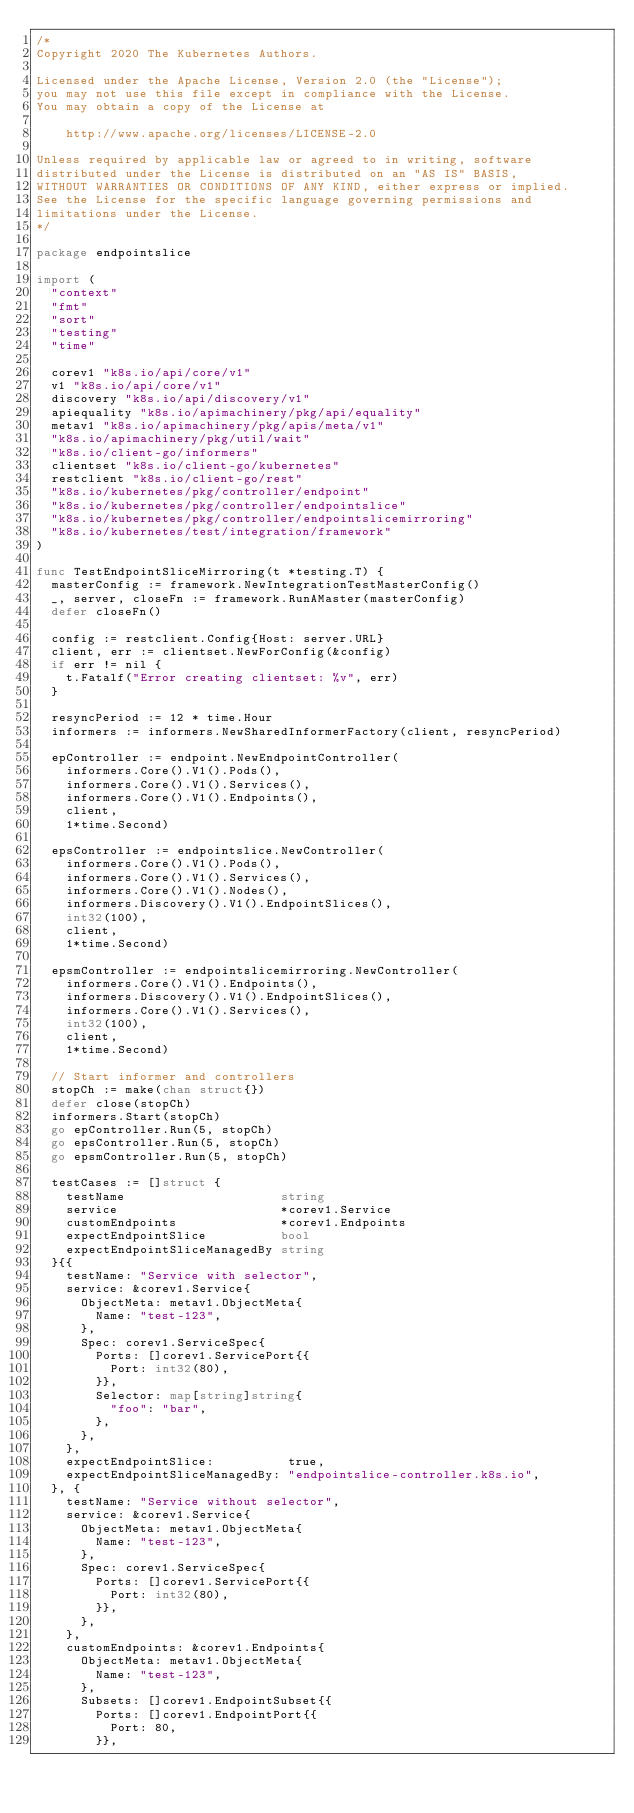Convert code to text. <code><loc_0><loc_0><loc_500><loc_500><_Go_>/*
Copyright 2020 The Kubernetes Authors.

Licensed under the Apache License, Version 2.0 (the "License");
you may not use this file except in compliance with the License.
You may obtain a copy of the License at

    http://www.apache.org/licenses/LICENSE-2.0

Unless required by applicable law or agreed to in writing, software
distributed under the License is distributed on an "AS IS" BASIS,
WITHOUT WARRANTIES OR CONDITIONS OF ANY KIND, either express or implied.
See the License for the specific language governing permissions and
limitations under the License.
*/

package endpointslice

import (
	"context"
	"fmt"
	"sort"
	"testing"
	"time"

	corev1 "k8s.io/api/core/v1"
	v1 "k8s.io/api/core/v1"
	discovery "k8s.io/api/discovery/v1"
	apiequality "k8s.io/apimachinery/pkg/api/equality"
	metav1 "k8s.io/apimachinery/pkg/apis/meta/v1"
	"k8s.io/apimachinery/pkg/util/wait"
	"k8s.io/client-go/informers"
	clientset "k8s.io/client-go/kubernetes"
	restclient "k8s.io/client-go/rest"
	"k8s.io/kubernetes/pkg/controller/endpoint"
	"k8s.io/kubernetes/pkg/controller/endpointslice"
	"k8s.io/kubernetes/pkg/controller/endpointslicemirroring"
	"k8s.io/kubernetes/test/integration/framework"
)

func TestEndpointSliceMirroring(t *testing.T) {
	masterConfig := framework.NewIntegrationTestMasterConfig()
	_, server, closeFn := framework.RunAMaster(masterConfig)
	defer closeFn()

	config := restclient.Config{Host: server.URL}
	client, err := clientset.NewForConfig(&config)
	if err != nil {
		t.Fatalf("Error creating clientset: %v", err)
	}

	resyncPeriod := 12 * time.Hour
	informers := informers.NewSharedInformerFactory(client, resyncPeriod)

	epController := endpoint.NewEndpointController(
		informers.Core().V1().Pods(),
		informers.Core().V1().Services(),
		informers.Core().V1().Endpoints(),
		client,
		1*time.Second)

	epsController := endpointslice.NewController(
		informers.Core().V1().Pods(),
		informers.Core().V1().Services(),
		informers.Core().V1().Nodes(),
		informers.Discovery().V1().EndpointSlices(),
		int32(100),
		client,
		1*time.Second)

	epsmController := endpointslicemirroring.NewController(
		informers.Core().V1().Endpoints(),
		informers.Discovery().V1().EndpointSlices(),
		informers.Core().V1().Services(),
		int32(100),
		client,
		1*time.Second)

	// Start informer and controllers
	stopCh := make(chan struct{})
	defer close(stopCh)
	informers.Start(stopCh)
	go epController.Run(5, stopCh)
	go epsController.Run(5, stopCh)
	go epsmController.Run(5, stopCh)

	testCases := []struct {
		testName                     string
		service                      *corev1.Service
		customEndpoints              *corev1.Endpoints
		expectEndpointSlice          bool
		expectEndpointSliceManagedBy string
	}{{
		testName: "Service with selector",
		service: &corev1.Service{
			ObjectMeta: metav1.ObjectMeta{
				Name: "test-123",
			},
			Spec: corev1.ServiceSpec{
				Ports: []corev1.ServicePort{{
					Port: int32(80),
				}},
				Selector: map[string]string{
					"foo": "bar",
				},
			},
		},
		expectEndpointSlice:          true,
		expectEndpointSliceManagedBy: "endpointslice-controller.k8s.io",
	}, {
		testName: "Service without selector",
		service: &corev1.Service{
			ObjectMeta: metav1.ObjectMeta{
				Name: "test-123",
			},
			Spec: corev1.ServiceSpec{
				Ports: []corev1.ServicePort{{
					Port: int32(80),
				}},
			},
		},
		customEndpoints: &corev1.Endpoints{
			ObjectMeta: metav1.ObjectMeta{
				Name: "test-123",
			},
			Subsets: []corev1.EndpointSubset{{
				Ports: []corev1.EndpointPort{{
					Port: 80,
				}},</code> 